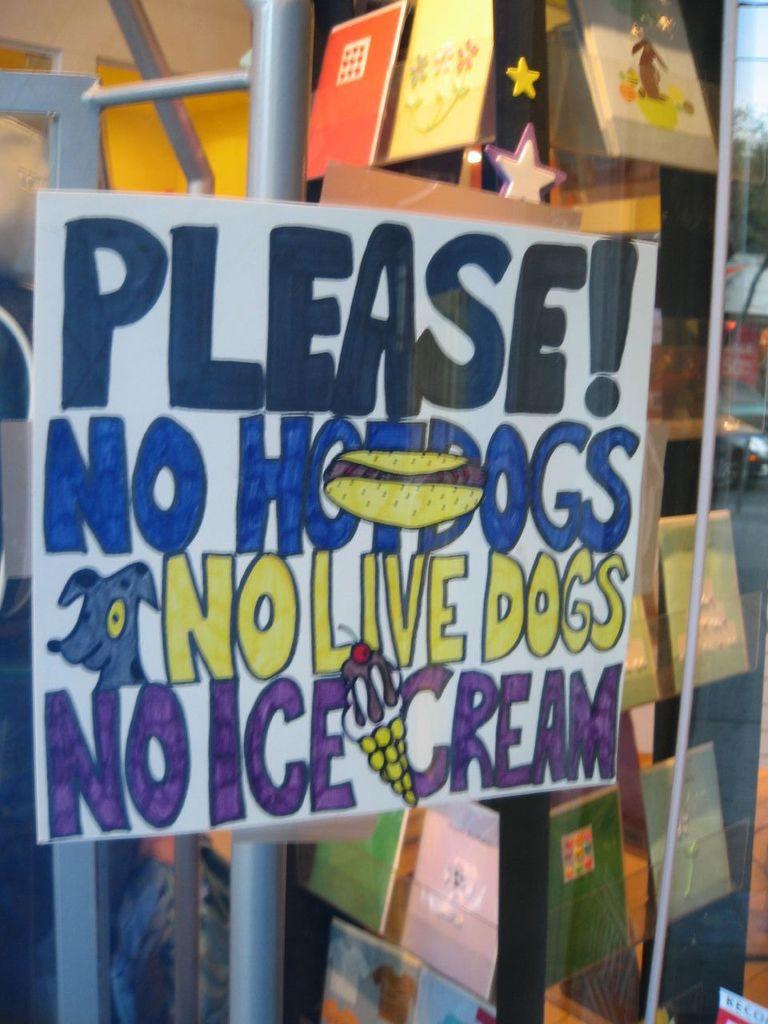What is the first word of the sign?
Provide a succinct answer. Please. What is not allowed according to the sign?
Your answer should be very brief. Hotdogs. 